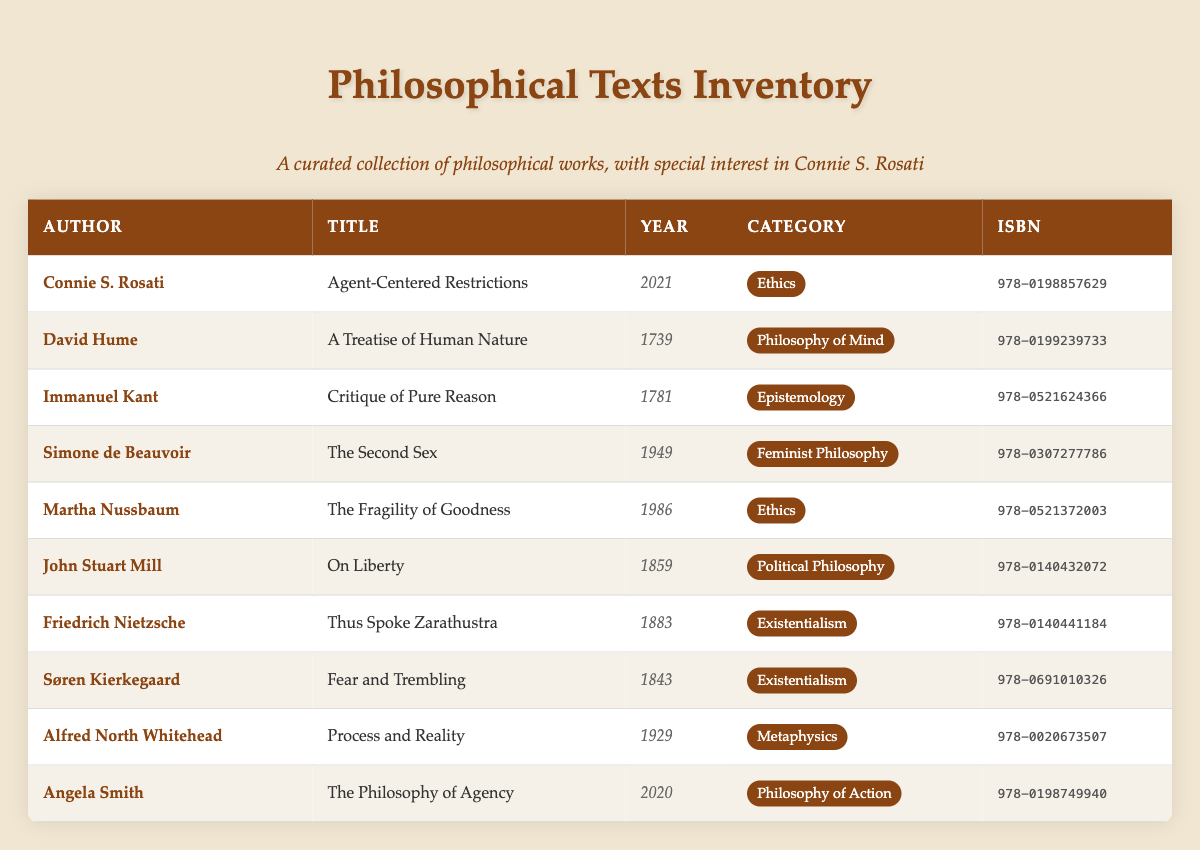What is the title of the book authored by Connie S. Rosati? The table shows a list of books, and to find the title authored by Connie S. Rosati, we look for the row where her name appears in the "Author" column. The corresponding title in that row is "Agent-Centered Restrictions."
Answer: Agent-Centered Restrictions Which book was published in 1949? Referring to the publication years in the "Year" column, we look through the table to find the year 1949. The corresponding title in that row is "The Second Sex" by Simone de Beauvoir.
Answer: The Second Sex How many books are categorized under Ethics? We can count the rows where the "Category" column indicates "Ethics." Scanning the table, we see that there are two books under this category: "Agent-Centered Restrictions" and "The Fragility of Goodness." The total is 2.
Answer: 2 Is Alfred North Whitehead's book categorized under Philosophy of Action? We check the "Category" for the row corresponding to Alfred North Whitehead's entry. The category listed is "Metaphysics," not "Philosophy of Action," making the statement false.
Answer: No Which author has the most recently published work, and what is the title? To determine the most recently published work, we check the "Publication Year" column for the highest value. The most recent year is 2021, which corresponds to "Agent-Centered Restrictions" by Connie S. Rosati.
Answer: Connie S. Rosati; Agent-Centered Restrictions What is the difference between the publication years of the earliest and latest texts in the list? We identify the earliest publication year (1739 for Hume's work) and the latest (2021 for Rosati's work). The difference is calculated as 2021 - 1739 = 282.
Answer: 282 Is "Thus Spoke Zarathustra" authored by Friedrich Nietzsche published before 1900? Checking the "Year" for Nietzsche’s work, it was published in 1883, which is indeed before 1900, making the statement true.
Answer: Yes What are the titles of the books available in the Existentialism category? We look for rows under the "Category" column that specify "Existentialism." The books in this category are "Thus Spoke Zarathustra" by Friedrich Nietzsche and "Fear and Trembling" by Søren Kierkegaard.
Answer: Thus Spoke Zarathustra; Fear and Trembling 